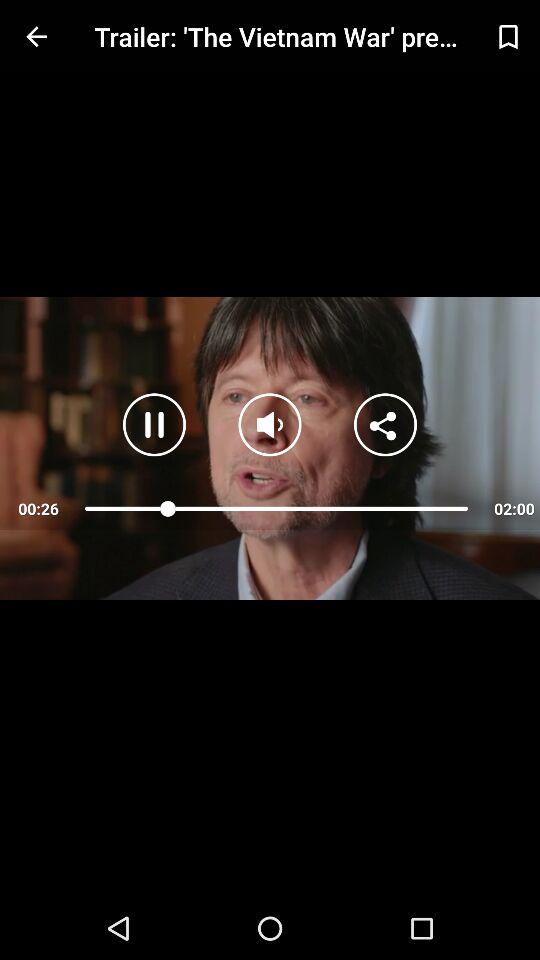What is the title? The title is "Trailer: 'The Vietnam War' pre...". 